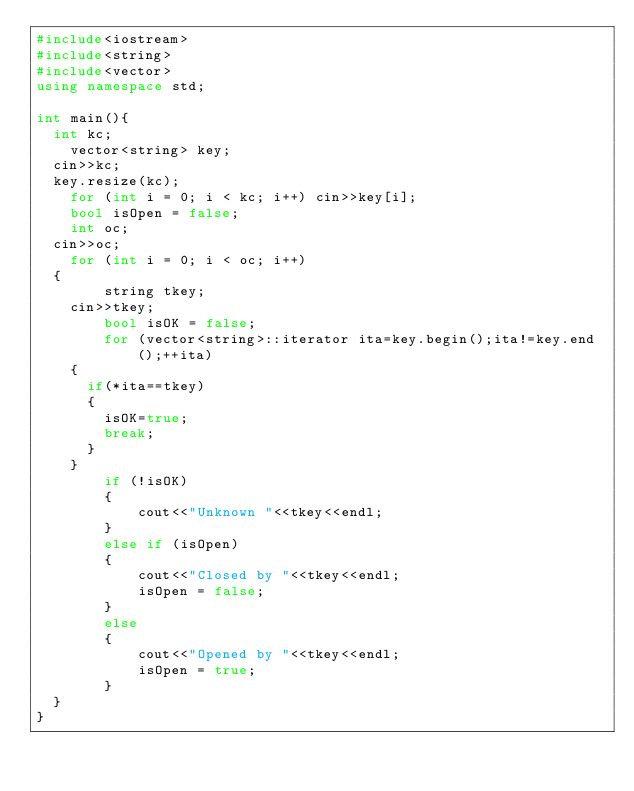Convert code to text. <code><loc_0><loc_0><loc_500><loc_500><_C++_>#include<iostream>
#include<string>
#include<vector>
using namespace std;

int main(){
	int kc;
    vector<string> key;
	cin>>kc;
	key.resize(kc);
    for (int i = 0; i < kc; i++) cin>>key[i];
    bool isOpen = false;
    int oc;
	cin>>oc;
    for (int i = 0; i < oc; i++)
	{
        string tkey;
		cin>>tkey;
        bool isOK = false;
        for (vector<string>::iterator ita=key.begin();ita!=key.end();++ita)
		{
			if(*ita==tkey)
			{
				isOK=true;
				break;
			}
		}		
        if (!isOK)
        {
            cout<<"Unknown "<<tkey<<endl;
        }
        else if (isOpen)
        {
            cout<<"Closed by "<<tkey<<endl;
            isOpen = false;
        }
        else
        {
            cout<<"Opened by "<<tkey<<endl;
            isOpen = true;
        }
	}
}</code> 